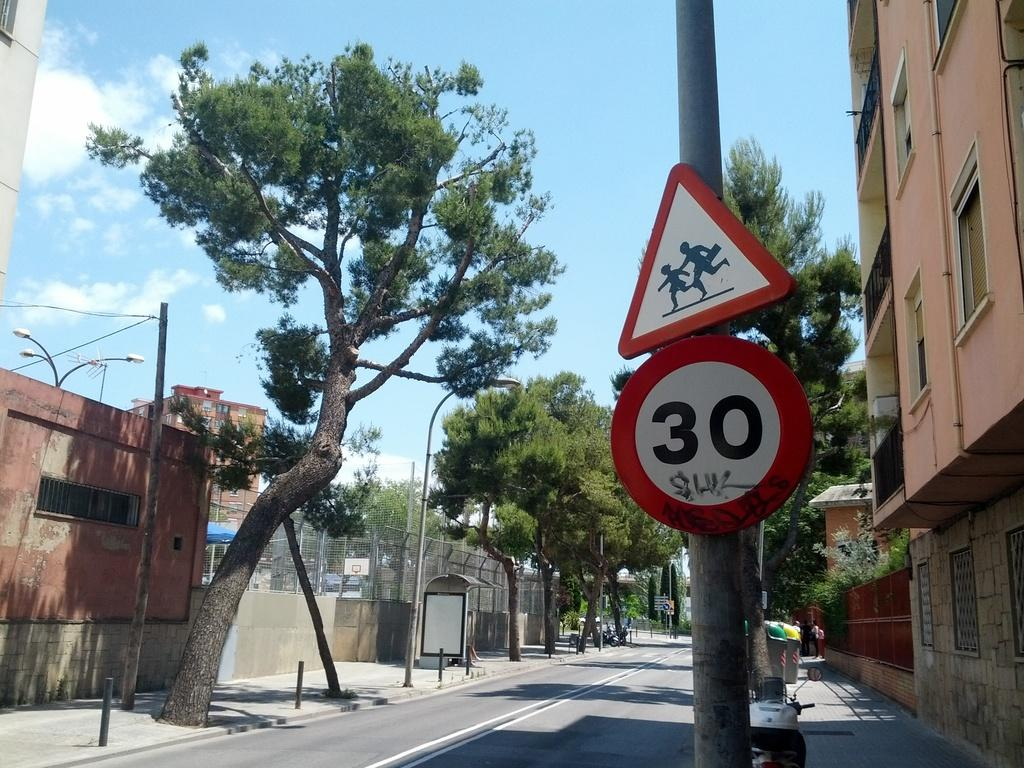<image>
Render a clear and concise summary of the photo. a street sign that is orange and white and black with the number 30 on it 